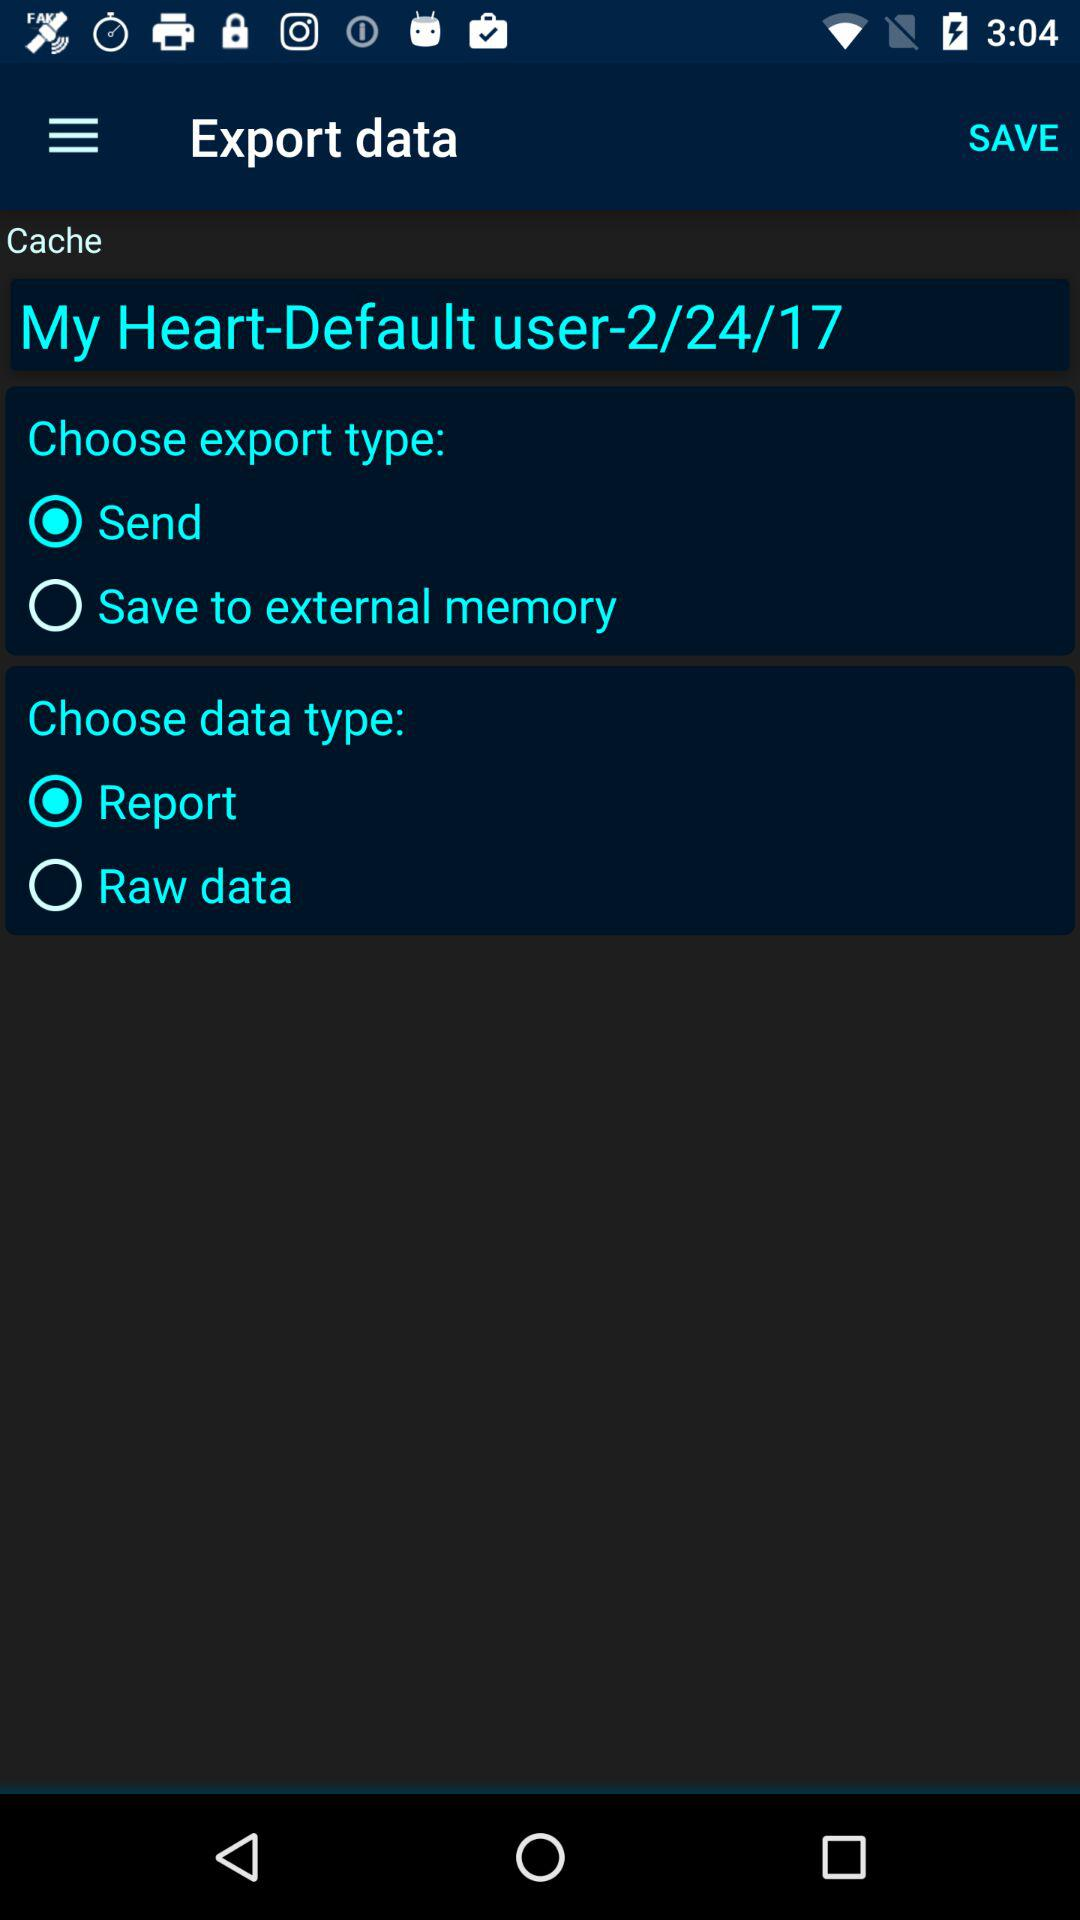How many data types are available to export?
Answer the question using a single word or phrase. 2 